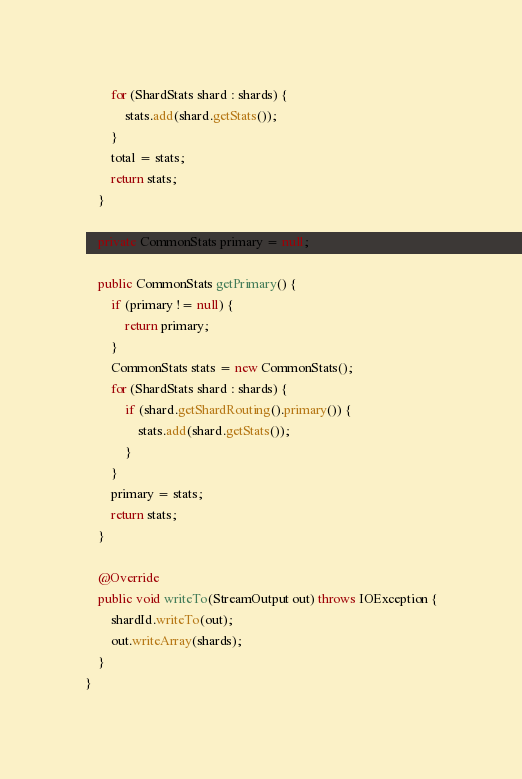Convert code to text. <code><loc_0><loc_0><loc_500><loc_500><_Java_>        for (ShardStats shard : shards) {
            stats.add(shard.getStats());
        }
        total = stats;
        return stats;
    }

    private CommonStats primary = null;

    public CommonStats getPrimary() {
        if (primary != null) {
            return primary;
        }
        CommonStats stats = new CommonStats();
        for (ShardStats shard : shards) {
            if (shard.getShardRouting().primary()) {
                stats.add(shard.getStats());
            }
        }
        primary = stats;
        return stats;
    }

    @Override
    public void writeTo(StreamOutput out) throws IOException {
        shardId.writeTo(out);
        out.writeArray(shards);
    }
}
</code> 